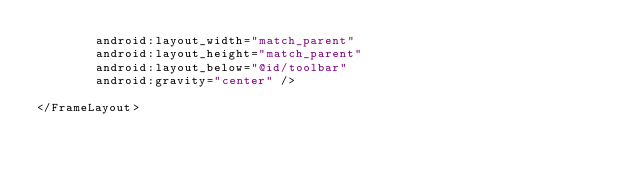<code> <loc_0><loc_0><loc_500><loc_500><_XML_>        android:layout_width="match_parent"
        android:layout_height="match_parent"
        android:layout_below="@id/toolbar"
        android:gravity="center" />

</FrameLayout>
</code> 